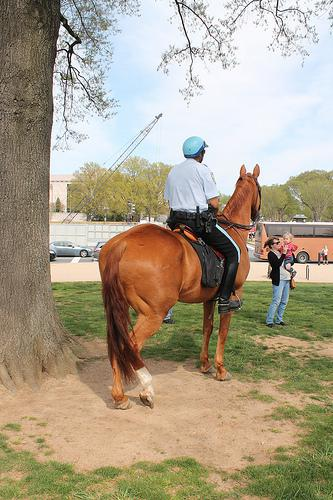Question: what is behind the woman?
Choices:
A. A tree.
B. A bus.
C. Her dog.
D. A building.
Answer with the letter. Answer: B Question: who is riding the horse?
Choices:
A. A man.
B. A woman.
C. A boy.
D. A police.
Answer with the letter. Answer: D Question: when was the pic teken?
Choices:
A. At night.
B. At dusk.
C. During the day.
D. At sunset.
Answer with the letter. Answer: C 